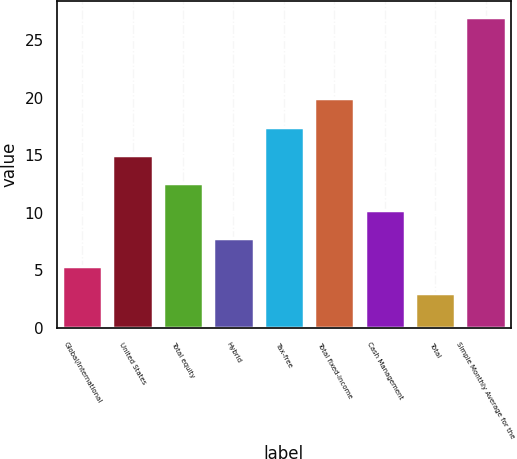Convert chart to OTSL. <chart><loc_0><loc_0><loc_500><loc_500><bar_chart><fcel>Global/international<fcel>United States<fcel>Total equity<fcel>Hybrid<fcel>Tax-free<fcel>Total fixed-income<fcel>Cash Management<fcel>Total<fcel>Simple Monthly Average for the<nl><fcel>5.4<fcel>15<fcel>12.6<fcel>7.8<fcel>17.4<fcel>20<fcel>10.2<fcel>3<fcel>27<nl></chart> 